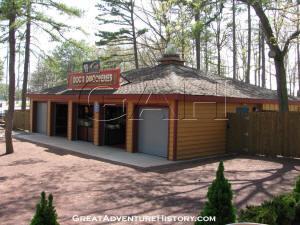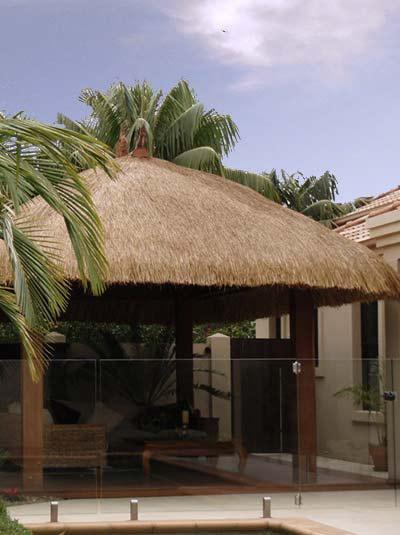The first image is the image on the left, the second image is the image on the right. Examine the images to the left and right. Is the description "The right image shows a non-tiered thatch roof over an open-sided structure with square columns in the corners." accurate? Answer yes or no. Yes. The first image is the image on the left, the second image is the image on the right. Assess this claim about the two images: "Both of the structures are enclosed". Correct or not? Answer yes or no. No. 